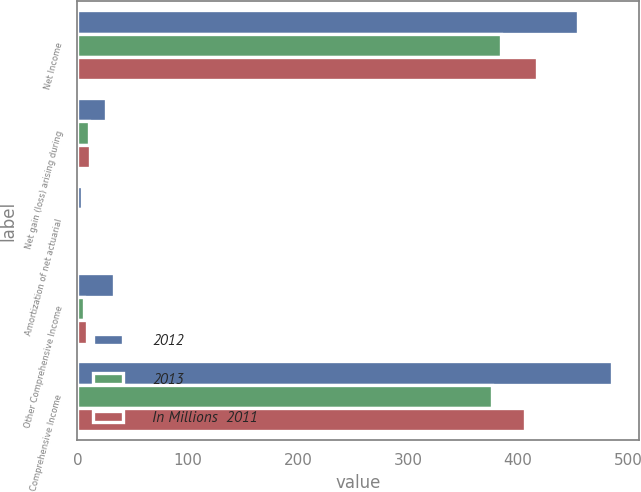Convert chart to OTSL. <chart><loc_0><loc_0><loc_500><loc_500><stacked_bar_chart><ecel><fcel>Net Income<fcel>Net gain (loss) arising during<fcel>Amortization of net actuarial<fcel>Other Comprehensive Income<fcel>Comprehensive Income<nl><fcel>2012<fcel>454<fcel>26<fcel>4<fcel>33<fcel>485<nl><fcel>2013<fcel>384<fcel>10<fcel>2<fcel>6<fcel>376<nl><fcel>In Millions  2011<fcel>417<fcel>11<fcel>2<fcel>9<fcel>406<nl></chart> 